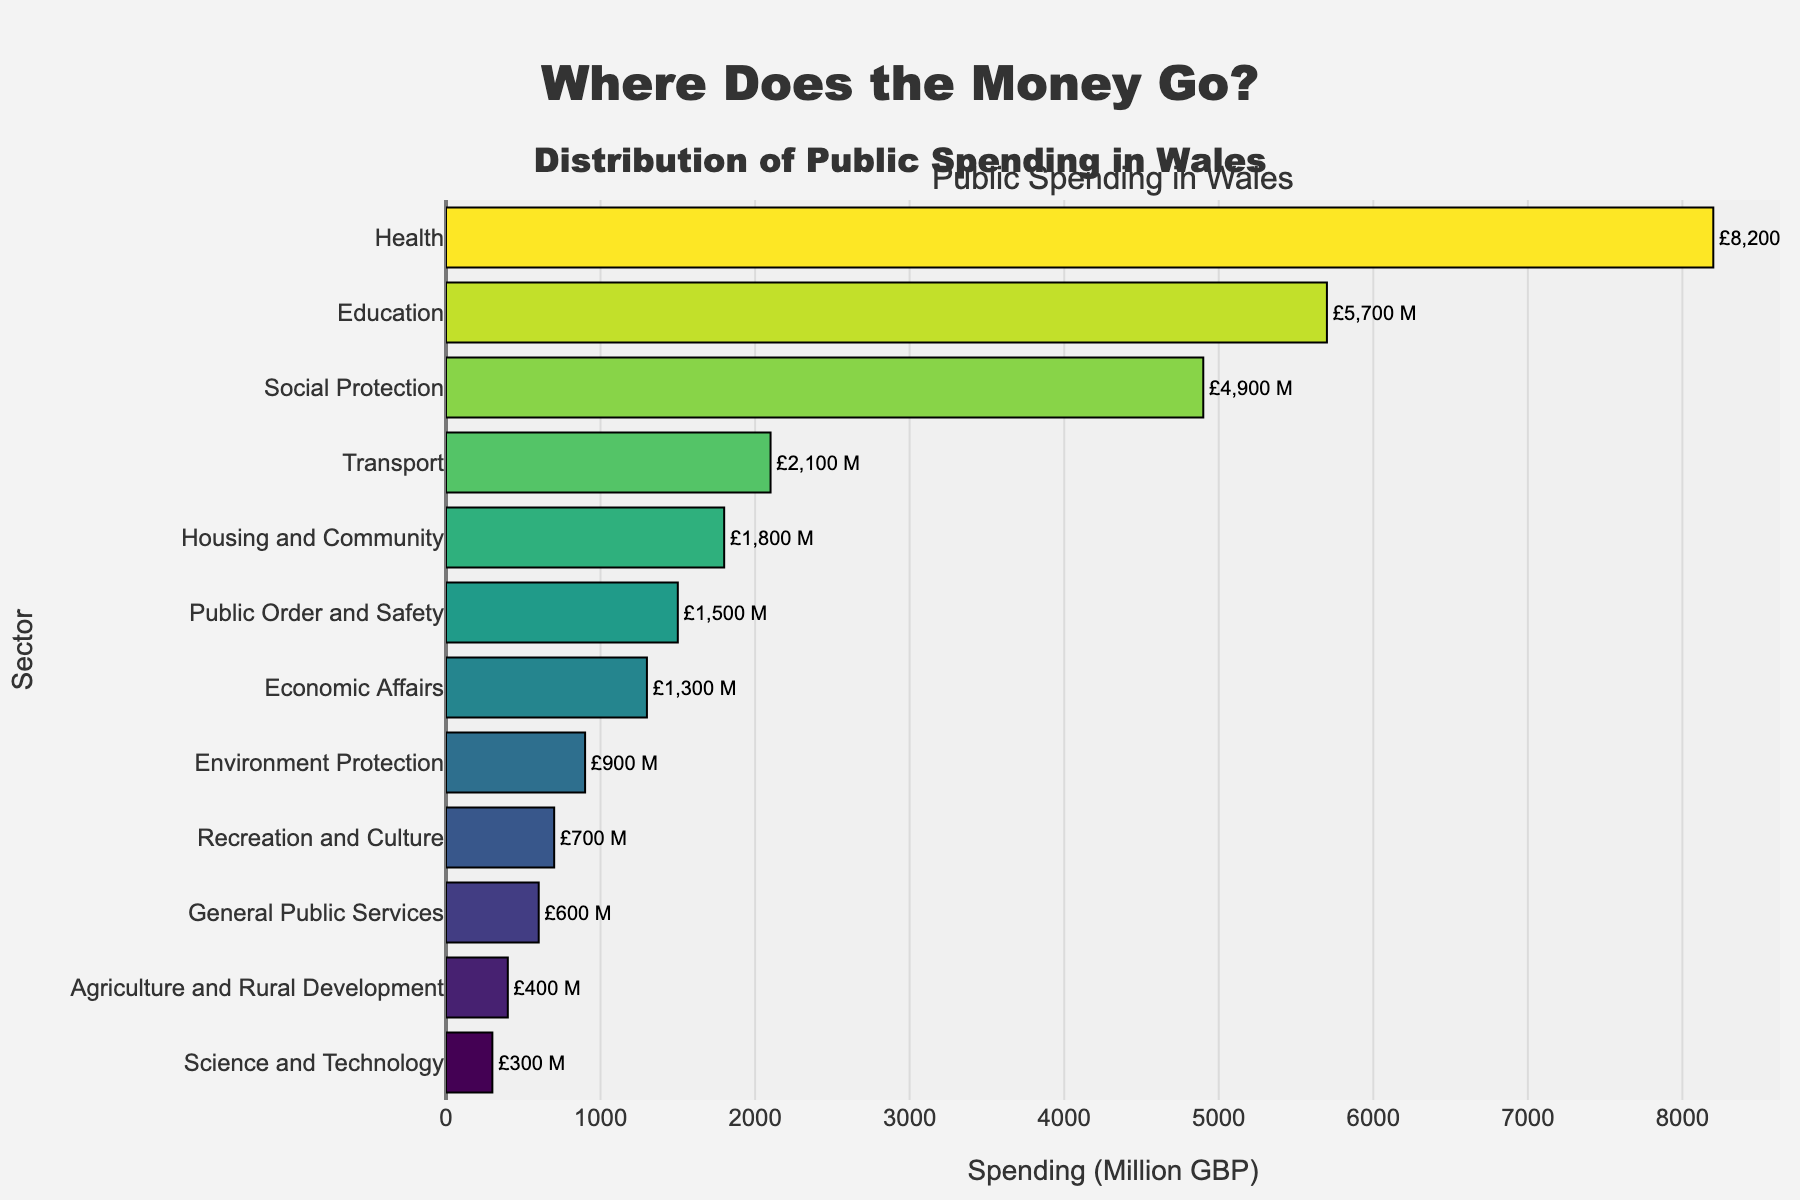Which sector has the highest public spending? The Health sector has a spending of £8,200 Million, which is the highest among all the sectors shown in the figure.
Answer: Health Which sector has the lowest public spending? The Science and Technology sector has the lowest spending with only £300 Million.
Answer: Science and Technology How much more is spent on Health compared to Education? Health spending is £8,200 Million while Education spending is £5,700 Million. The difference is £8,200 Million - £5,700 Million = £2,500 Million.
Answer: £2,500 Million What is the total spending on Transport and Housing and Community combined? Transport has a spending of £2,100 Million and Housing and Community has £1,800 Million. The combined spending is £2,100 Million + £1,800 Million = £3,900 Million.
Answer: £3,900 Million Which sector has a higher spending, Agriculture and Rural Development or Recreation and Culture? Recreation and Culture has a spending of £700 Million while Agriculture and Rural Development has £400 Million. Therefore, Recreation and Culture has higher spending.
Answer: Recreation and Culture What is the average spending of the top three sectors? The top three sectors are Health (£8,200 Million), Education (£5,700 Million), and Social Protection (£4,900 Million). The average is (8,200 + 5,700 + 4,900) / 3 = 18,800 / 3 = 6,266.67 Million.
Answer: £6,266.67 Million How does the spending on Public Order and Safety compare to that on Economic Affairs? Public Order and Safety has a spending of £1,500 Million, while Economic Affairs has £1,300 Million. Therefore, Public Order and Safety has £200 Million more spending.
Answer: £200 Million more What percentage of the total spending is allocated to the Environment Protection sector? First, calculate the total spending for all sectors, which is 8200 + 5700 + 4900 + 2100 + 1800 + 1500 + 1300 + 900 + 700 + 600 + 400 + 300 = £32,400 Million. Environment Protection has £900 Million. The percentage is (900 / 32,400) * 100 ≈ 2.78%.
Answer: 2.78% If spending on Economic Affairs increased by 50%, what would the new spending amount be? The current spending on Economic Affairs is £1,300 Million. An increase of 50% would be 1,300 * 0.5 = 650 Million. The new spending amount would be 1,300 + 650 = £1,950 Million.
Answer: £1,950 Million Which sectors have spending amounts below the median value of all sectors? The median spending value can be found by arranging all spending values in ascending order: 300, 400, 600, 700, 900, 1300, 1500, 1800, 2100, 4900, 5700, 8200. The middle value is between 1300 and 1500, so the median is (1300 + 1500) / 2 = 1400. The sectors below this median value are Science and Technology, Agriculture and Rural Development, General Public Services, Recreation and Culture, Environment Protection, and Economic Affairs.
Answer: Science and Technology, Agriculture and Rural Development, General Public Services, Recreation and Culture, Environment Protection, Economic Affairs 